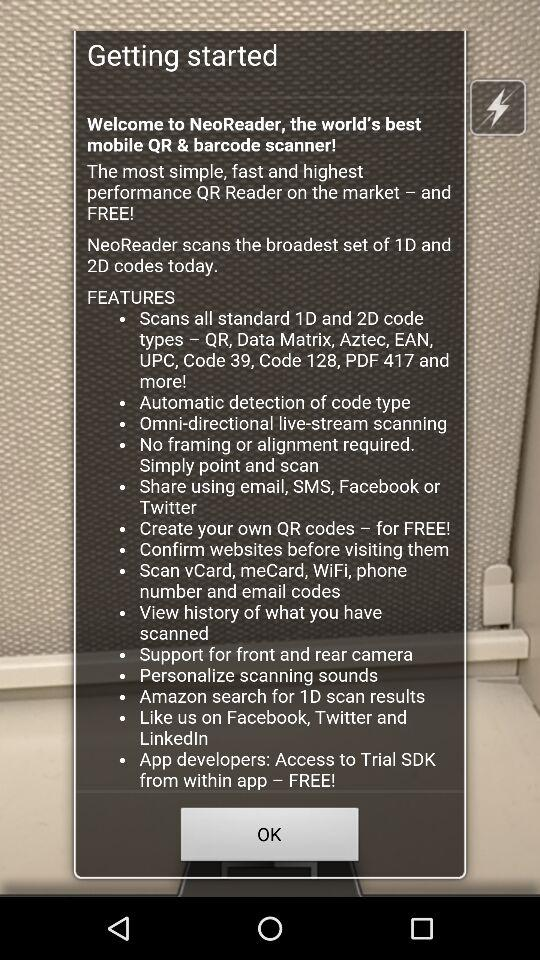On which platforms can we provide likes for the app? You can provide likes for the app on Facebook, Twitter and LinkedIn. 